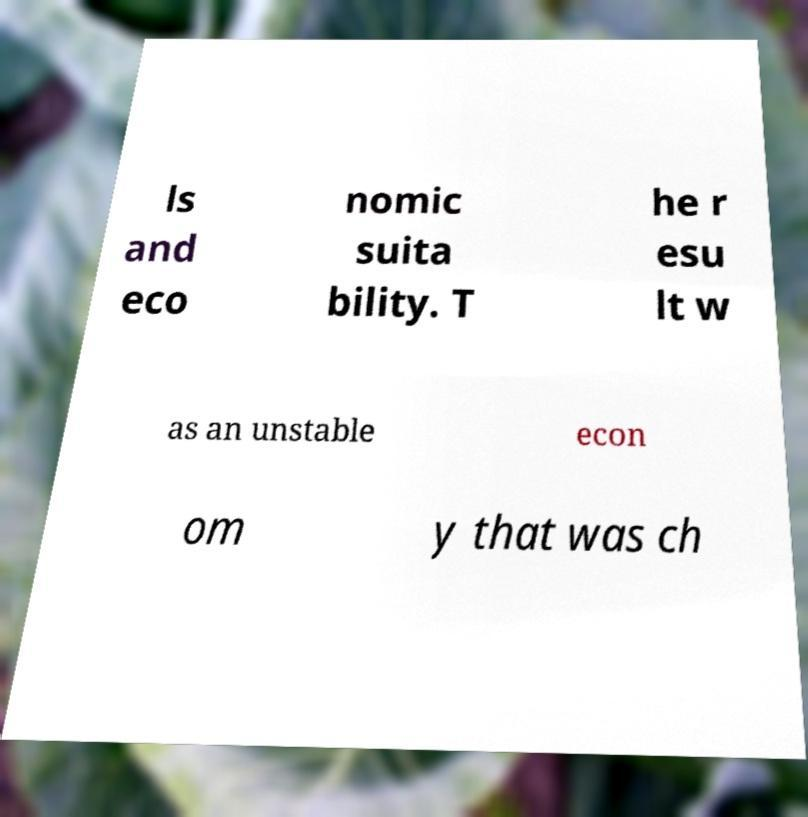There's text embedded in this image that I need extracted. Can you transcribe it verbatim? ls and eco nomic suita bility. T he r esu lt w as an unstable econ om y that was ch 